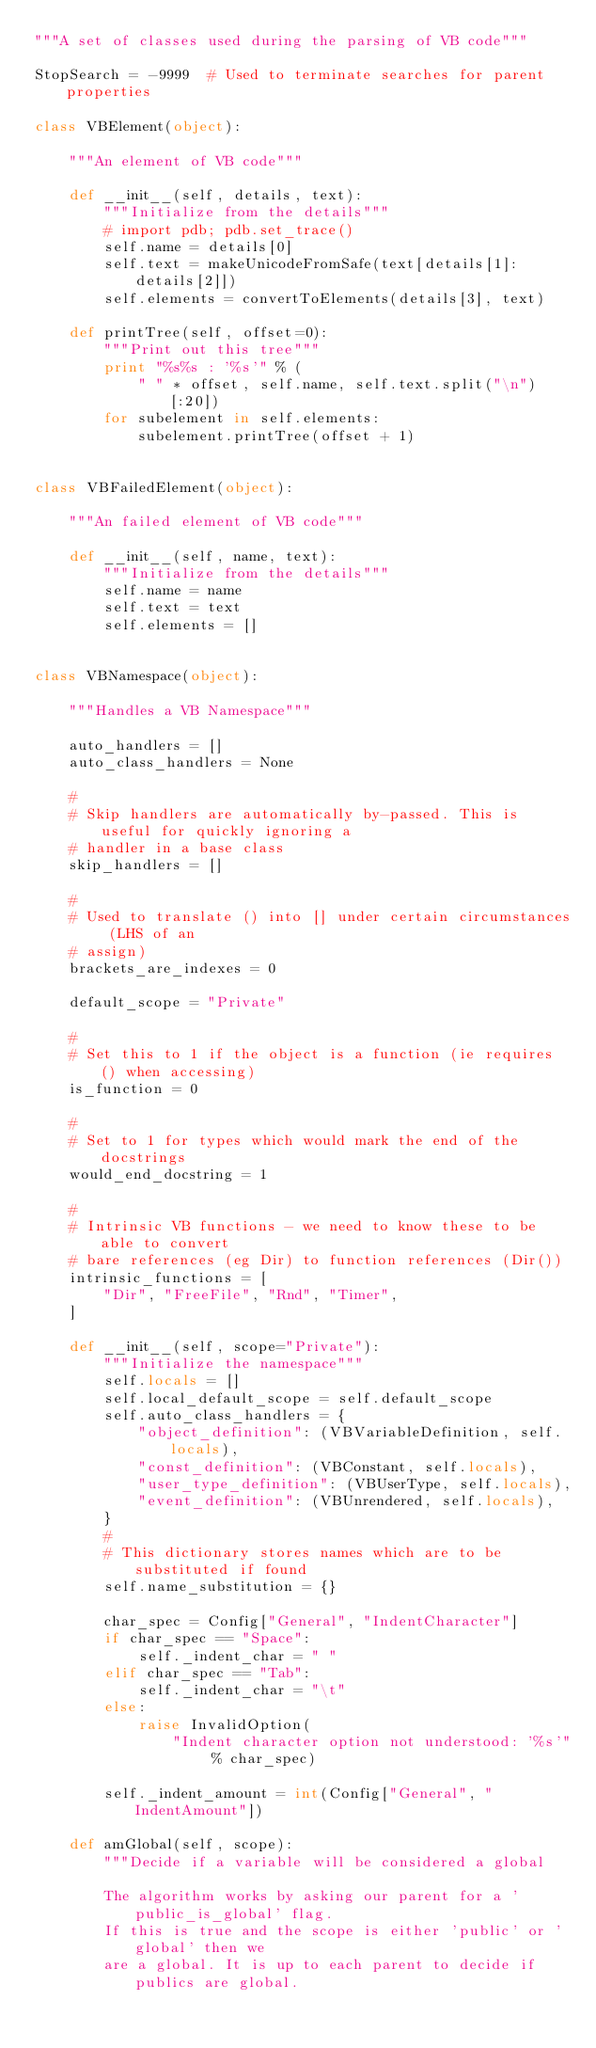Convert code to text. <code><loc_0><loc_0><loc_500><loc_500><_Python_>"""A set of classes used during the parsing of VB code"""

StopSearch = -9999  # Used to terminate searches for parent properties

class VBElement(object):

    """An element of VB code"""

    def __init__(self, details, text):
        """Initialize from the details"""
        # import pdb; pdb.set_trace()
        self.name = details[0]
        self.text = makeUnicodeFromSafe(text[details[1]:details[2]])
        self.elements = convertToElements(details[3], text)

    def printTree(self, offset=0):
        """Print out this tree"""
        print "%s%s : '%s'" % (
            " " * offset, self.name, self.text.split("\n")[:20])
        for subelement in self.elements:
            subelement.printTree(offset + 1)


class VBFailedElement(object):

    """An failed element of VB code"""

    def __init__(self, name, text):
        """Initialize from the details"""
        self.name = name
        self.text = text
        self.elements = []


class VBNamespace(object):

    """Handles a VB Namespace"""

    auto_handlers = []
    auto_class_handlers = None

    #
    # Skip handlers are automatically by-passed. This is useful for quickly ignoring a
    # handler in a base class
    skip_handlers = []

    #
    # Used to translate () into [] under certain circumstances (LHS of an
    # assign)
    brackets_are_indexes = 0

    default_scope = "Private"

    #
    # Set this to 1 if the object is a function (ie requires () when accessing)
    is_function = 0

    #
    # Set to 1 for types which would mark the end of the docstrings
    would_end_docstring = 1

    #
    # Intrinsic VB functions - we need to know these to be able to convert
    # bare references (eg Dir) to function references (Dir())
    intrinsic_functions = [
        "Dir", "FreeFile", "Rnd", "Timer",
    ]

    def __init__(self, scope="Private"):
        """Initialize the namespace"""
        self.locals = []
        self.local_default_scope = self.default_scope
        self.auto_class_handlers = {
            "object_definition": (VBVariableDefinition, self.locals),
            "const_definition": (VBConstant, self.locals),
            "user_type_definition": (VBUserType, self.locals),
            "event_definition": (VBUnrendered, self.locals),
        }
        #
        # This dictionary stores names which are to be substituted if found
        self.name_substitution = {}

        char_spec = Config["General", "IndentCharacter"]
        if char_spec == "Space":
            self._indent_char = " "
        elif char_spec == "Tab":
            self._indent_char = "\t"
        else:
            raise InvalidOption(
                "Indent character option not understood: '%s'" % char_spec)

        self._indent_amount = int(Config["General", "IndentAmount"])

    def amGlobal(self, scope):
        """Decide if a variable will be considered a global

        The algorithm works by asking our parent for a 'public_is_global' flag.
        If this is true and the scope is either 'public' or 'global' then we
        are a global. It is up to each parent to decide if publics are global.</code> 